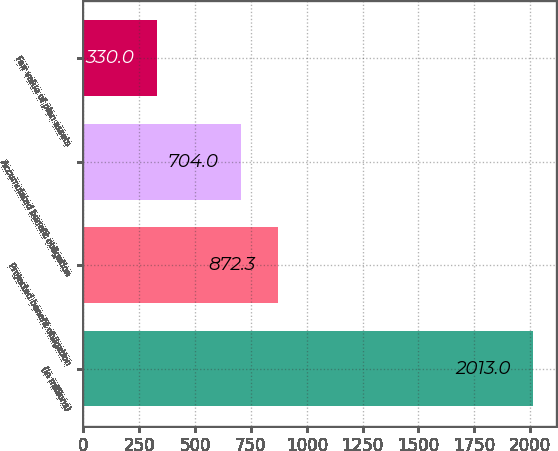Convert chart. <chart><loc_0><loc_0><loc_500><loc_500><bar_chart><fcel>(in millions)<fcel>Projected benefit obligation<fcel>Accumulated benefit obligation<fcel>Fair value of plan assets<nl><fcel>2013<fcel>872.3<fcel>704<fcel>330<nl></chart> 